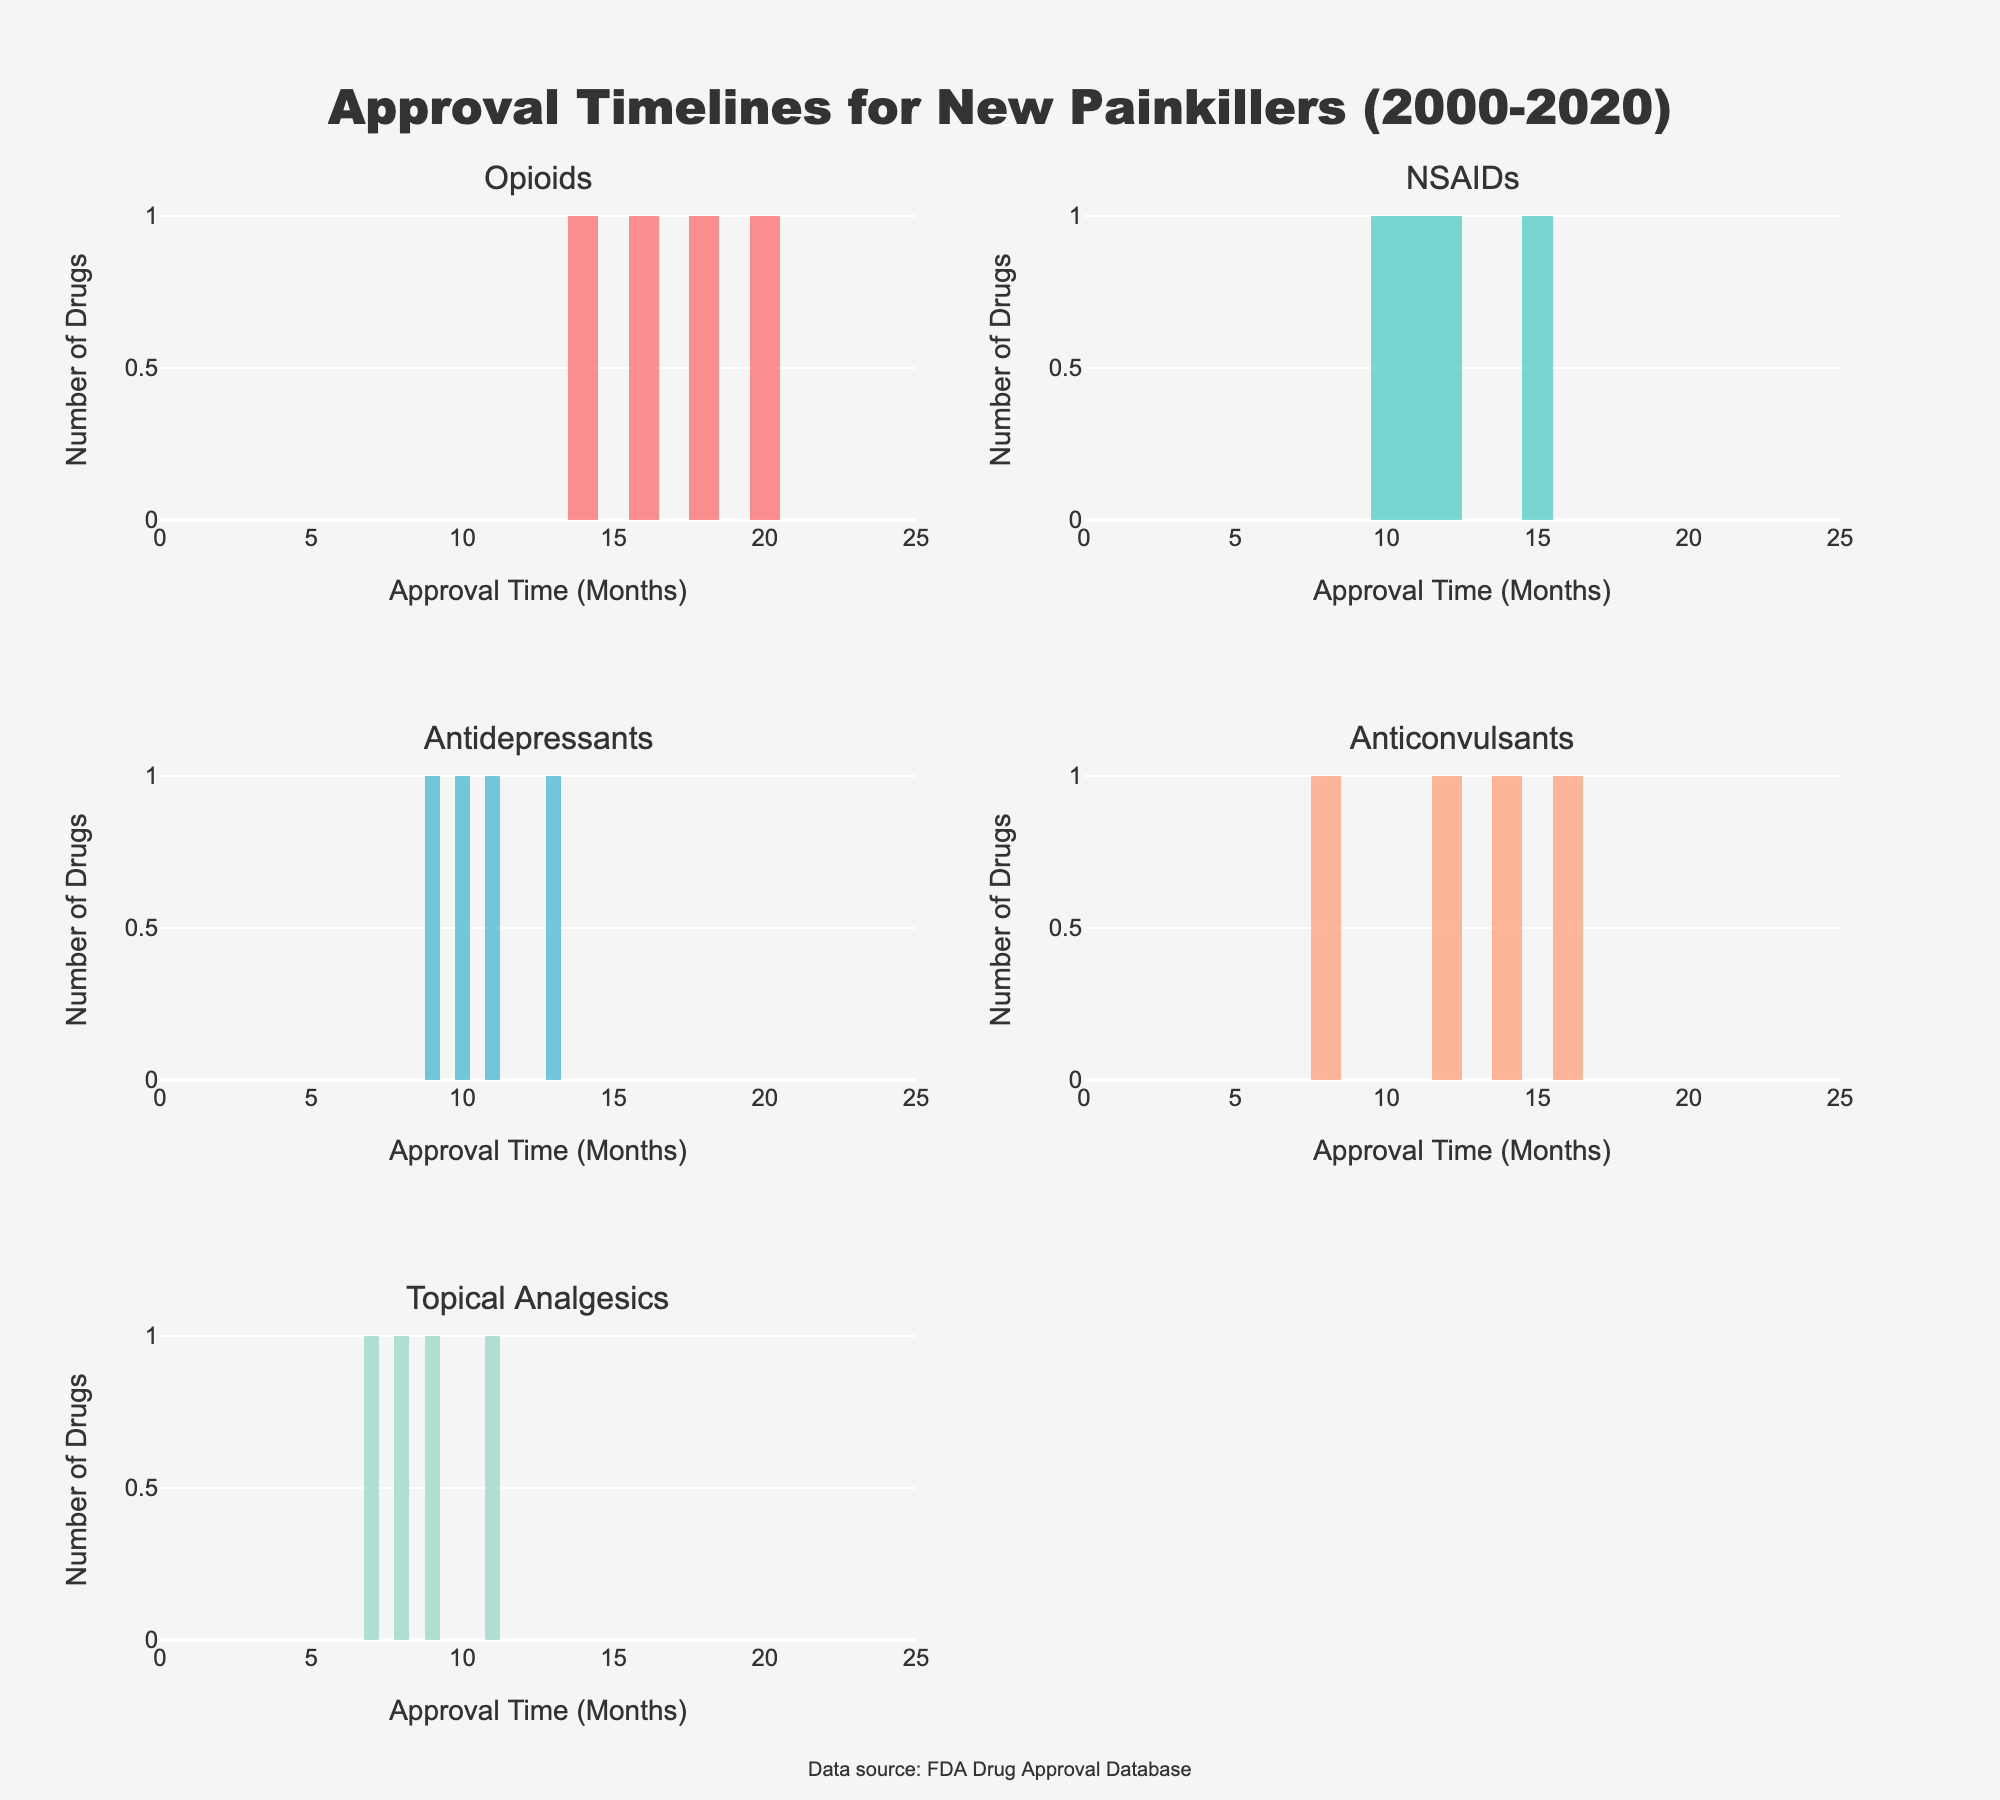What's the title of the figure? The title is typically displayed at the top of the figure and is meant to provide a brief summary of what the figure shows. In this case, it reads "Approval Timelines for New Painkillers (2000-2020)" directly above all subplots.
Answer: Approval Timelines for New Painkillers (2000-2020) How many drug classes are depicted in the subplots? The figure contains multiple subplots, each with a different title corresponding to a drug class. By counting these titles, you can determine the number of drug classes shown.
Answer: Five What is the range of the x-axis in the subplots? The x-axis in each subplot is labeled "Approval Time (Months)," and by checking its range, you see it spans from 0 to 25 months based on the ticks.
Answer: 0 to 25 How many drugs fall into the Opioids drug class? By looking at the histogram for the Opioids drug class, you can count the total number of bars representing each individual drug's approval time. The individual bars sum up the total count.
Answer: Four Which drug class has the shortest approval time and what is that time? The histogram for each drug class shows the distribution of approval times. By identifying the minimum x-value in each subplot, you can infer the shortest approval time. Lidoderm in the Topical Analgesics class has the shortest approval time of 7 months.
Answer: Topical Analgesics, 7 months What is the average approval time for NSAIDs? To find the average approval time, add the approval times for all NSAIDs drugs and divide by the number of NSAIDs drugs. The times are 12, 10, 15, and 11 months: (12+10+15+11) / 4 = 12 months.
Answer: 12 months Which drug class has the highest number of drugs approved within 10 months? By examining each histogram, count the bars that fall within the 0-10 months range for each drug class. The Topical Analgesics class has two drugs (Lidoderm and Voltaren Gel) approved within 10 months.
Answer: Topical Analgesics Is the approval time distribution for Antidepressants more concentrated or spread out compared to Opioids? By looking at the spread and heights of the bars in the histograms for Antidepressants and Opioids, you can observe their distribution. The Antidepressants class has a more concentrated distribution with approval times mostly around 10-13 months, whereas Opioids have a wider spread from 14-20 months.
Answer: More concentrated Which two drug classes have the same number of approved drugs? Count the number of individual bars in each histogram. Antidepressants and NSAIDs both have four drugs approved, resulting from their respective four bars in the subplots.
Answer: Antidepressants and NSAIDs 